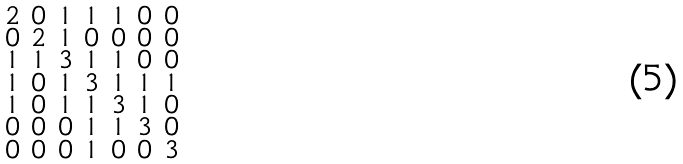Convert formula to latex. <formula><loc_0><loc_0><loc_500><loc_500>\begin{smallmatrix} 2 & 0 & 1 & 1 & 1 & 0 & 0 \\ 0 & 2 & 1 & 0 & 0 & 0 & 0 \\ 1 & 1 & 3 & 1 & 1 & 0 & 0 \\ 1 & 0 & 1 & 3 & 1 & 1 & 1 \\ 1 & 0 & 1 & 1 & 3 & 1 & 0 \\ 0 & 0 & 0 & 1 & 1 & 3 & 0 \\ 0 & 0 & 0 & 1 & 0 & 0 & 3 \end{smallmatrix}</formula> 